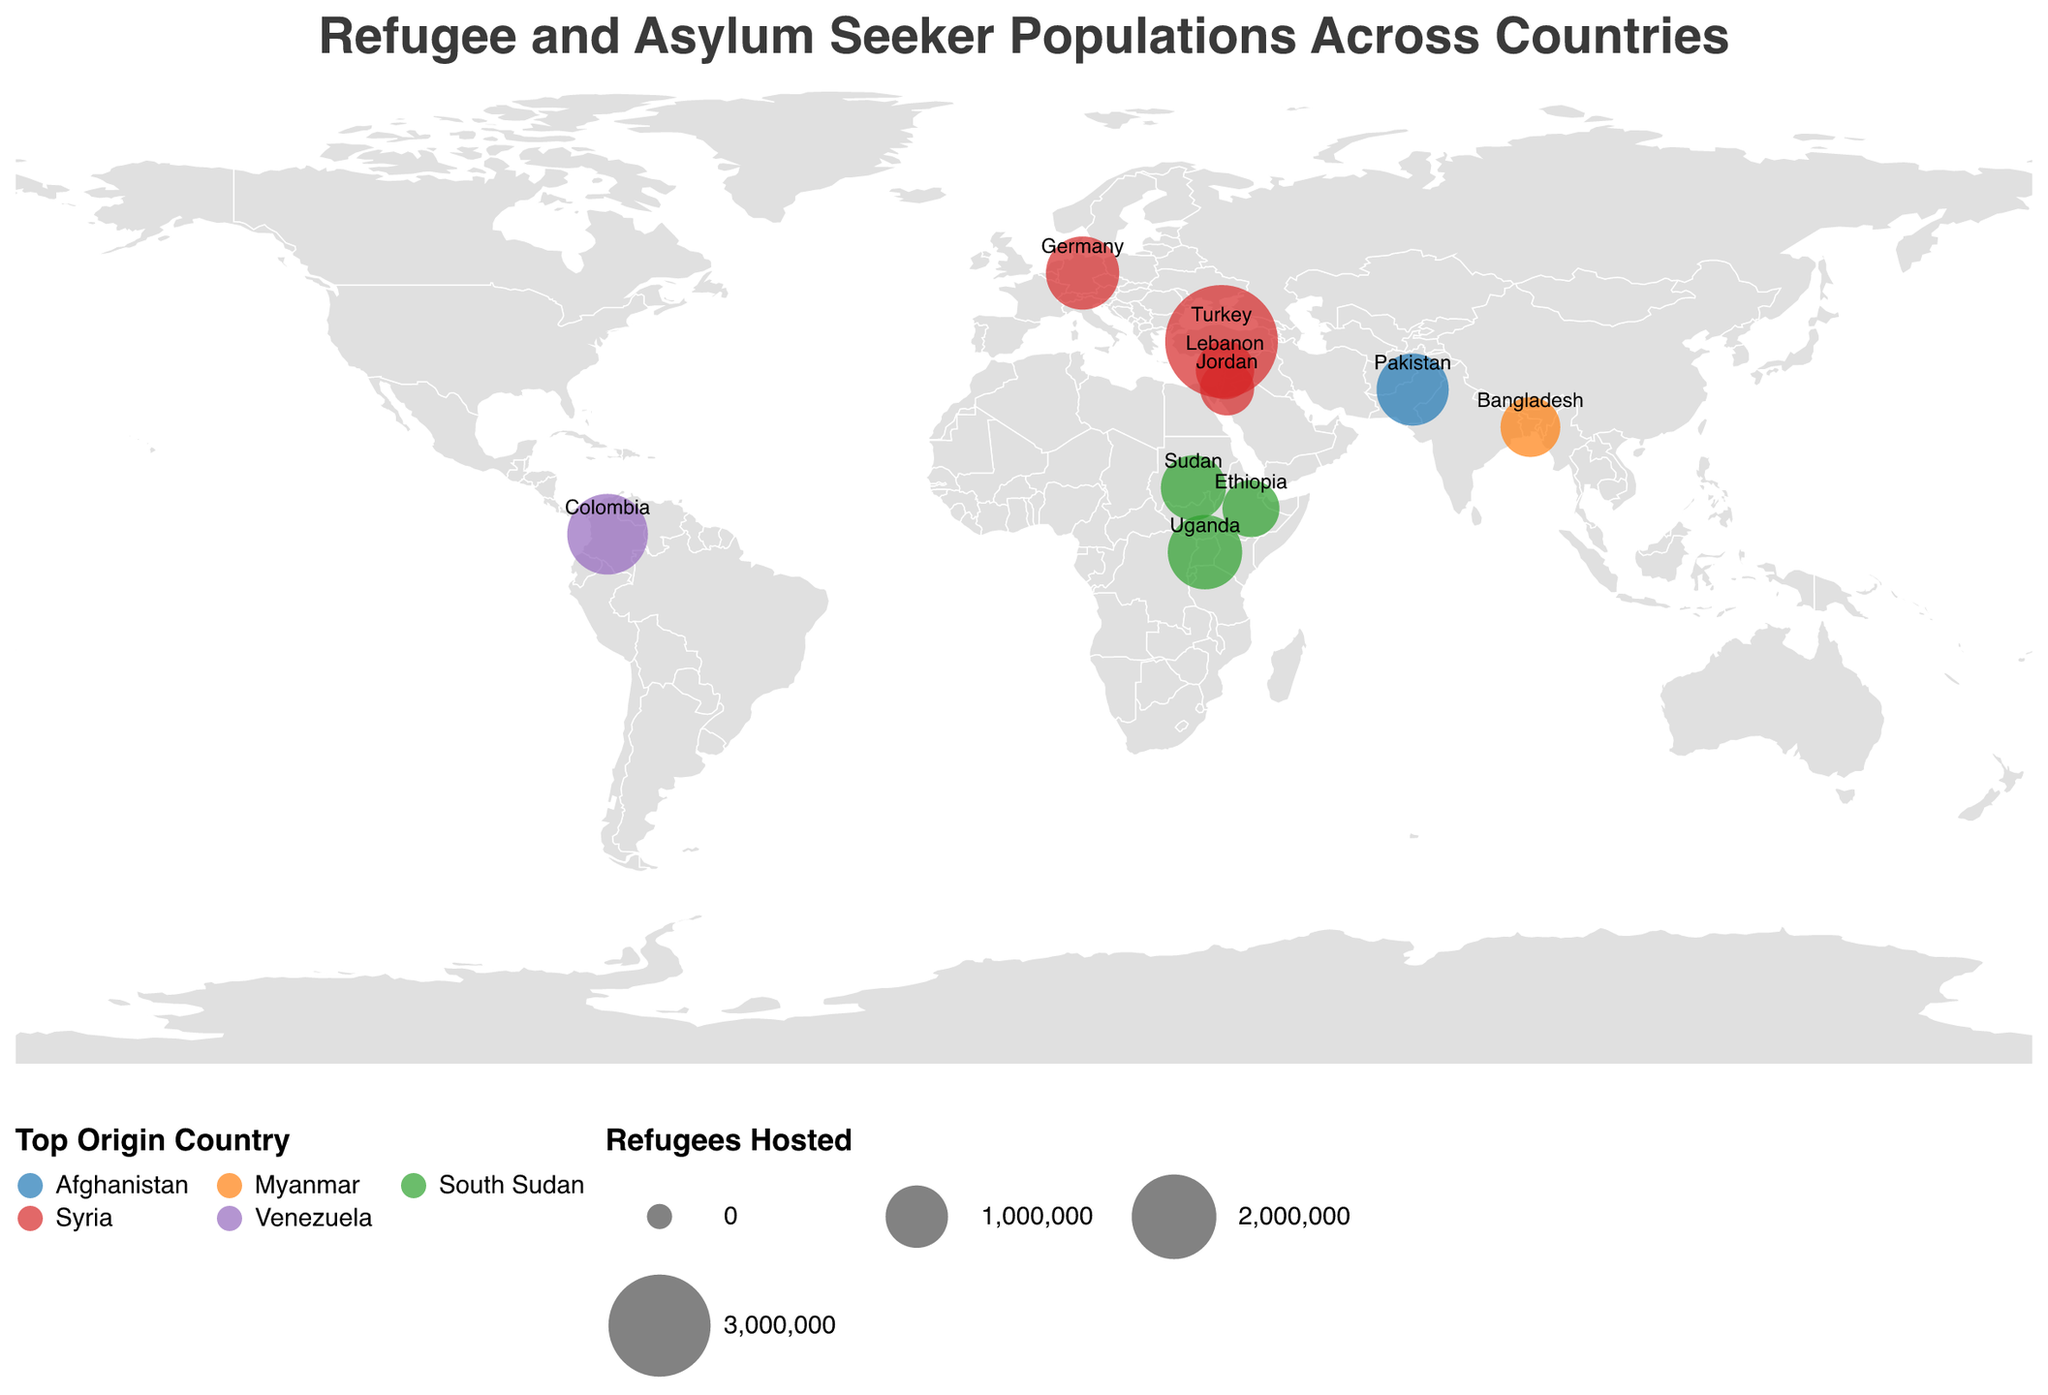Which country hosts the most refugees? By looking at the circles on the map, the largest circle represents the country with the most refugees hosted. Turkey has the largest circle.
Answer: Turkey Which country has the largest number of asylum seekers? The size of the circles also represents the number of asylum seekers, so we look for the largest circle with additional numbers. Germany has 350,000 asylum seekers, the highest number.
Answer: Germany What is the top origin country of refugees in Pakistan? Each circle's color represents the top origin country for that nation. For Pakistan, the legend indicates its color corresponds to Afghanistan.
Answer: Afghanistan How many countries in the plot have Syria as the top origin country for refugees? Cross-referencing the legend and data points, we find that Germany, Turkey, Lebanon, and Jordan all have Syria as their top origin country.
Answer: 4 Which country has the second largest number of refugees hosted and what is the top origin country for those refugees? Referring to the size of the circles again, the second largest after Turkey is Uganda. The top origin country for Uganda, according to the color legend, is South Sudan.
Answer: Uganda, South Sudan Compare the number of asylum seekers in Jordan and Lebanon; which is higher? Jordan has 55,000 asylum seekers, whereas Lebanon has 12,000. Thus, Jordan has more asylum seekers.
Answer: Jordan Which country primarily sends refugees to Australia? Looking at the data values and matching the main destination of refugees, Ethiopia is the country sending refugees primarily to Australia.
Answer: Ethiopia Which countries have the same top origin country for refugees? By matching colors (for origin country) across different countries, Turkey, Germany, Lebanon, and Jordan all have Syria as the top origin country, while Sudan, Uganda, and Ethiopia all have South Sudan as their top origin.
Answer: Turkey, Germany, Lebanon, Jordan, Sudan, Uganda, Ethiopia What is the total number of refugees hosted by Sudan and Pakistan combined? Adding up the number of refugees hosted by Sudan (1,100,000) and Pakistan (1,400,000) gives 2,500,000.
Answer: 2,500,000 Among the countries listed, which one sends the fewest asylum seekers to another country? According to the figure, Pakistan sends the fewest asylum seekers, which are 8,000.
Answer: Pakistan 